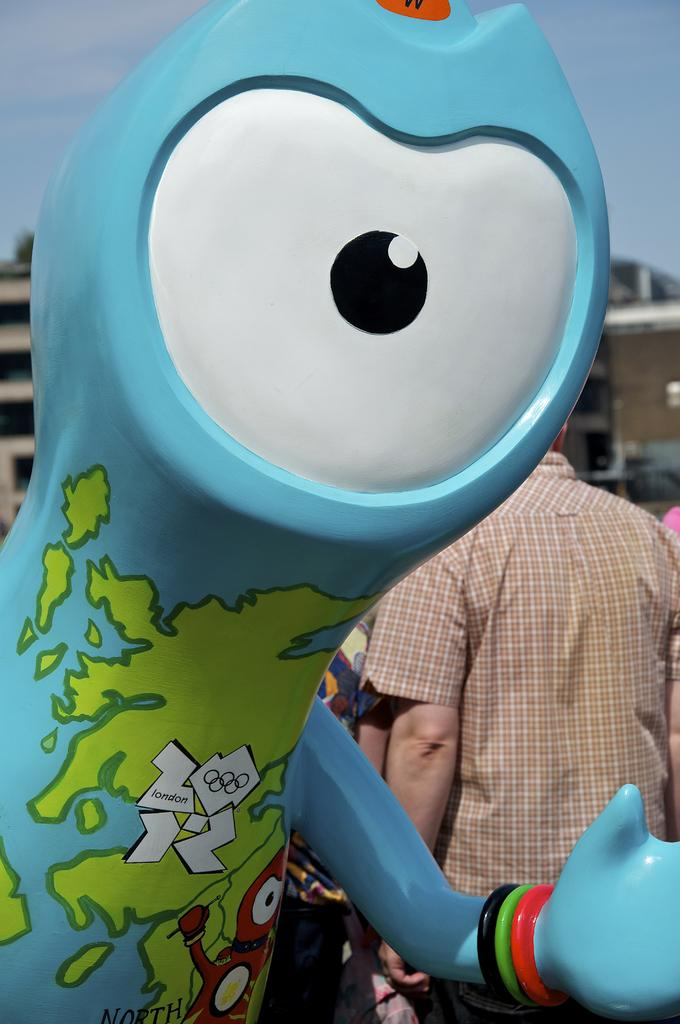What is the main subject of the picture? The main subject of the picture is a doll. Can you describe the doll's appearance? The doll has one eye, is blue in color, and has green color designs on it. Is there anyone else in the picture besides the doll? Yes, there is a person standing behind the doll. What type of friction can be seen between the doll and the person in the image? There is no friction visible between the doll and the person in the image. How many crows are perched on the doll's head in the image? There are no crows present in the image. 